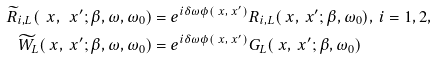Convert formula to latex. <formula><loc_0><loc_0><loc_500><loc_500>\widetilde { R } _ { i , L } ( \ x , \ x ^ { \prime } ; \beta , \omega , \omega _ { 0 } ) & = e ^ { i \delta \omega \phi ( \ x , \ x ^ { \prime } ) } R _ { i , L } ( \ x , \ x ^ { \prime } ; \beta , \omega _ { 0 } ) , \, i = 1 , 2 , \\ \widetilde { W } _ { L } ( \ x , \ x ^ { \prime } ; \beta , \omega , \omega _ { 0 } ) & = e ^ { i \delta \omega \phi ( \ x , \ x ^ { \prime } ) } G _ { L } ( \ x , \ x ^ { \prime } ; \beta , \omega _ { 0 } )</formula> 